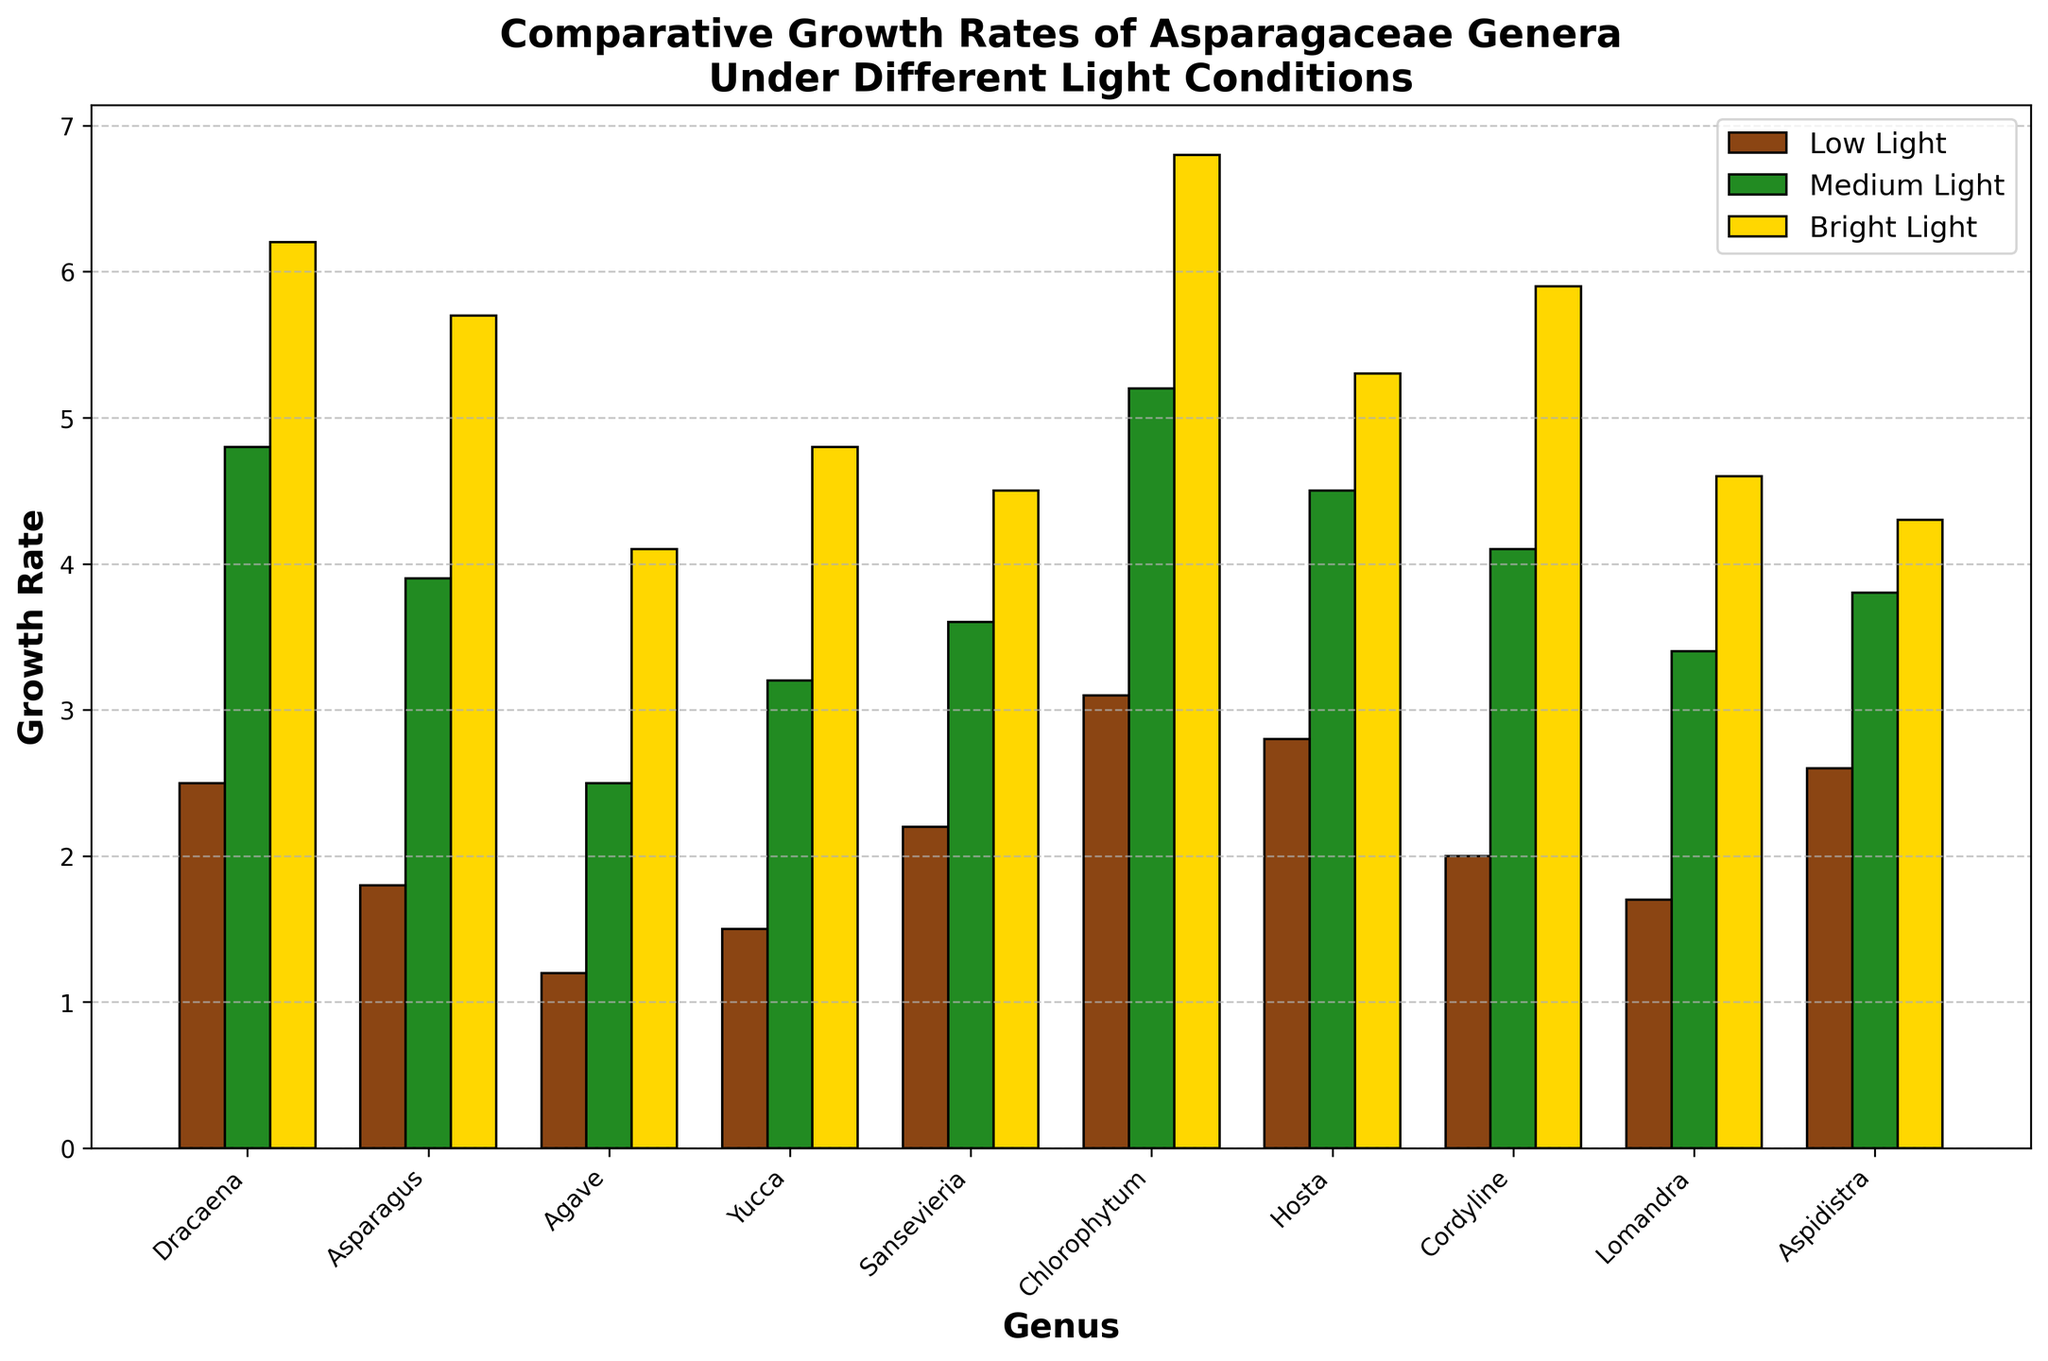Which genus has the highest growth rate under bright light? Look at the “Bright Light” bars and identify the tallest one. Chlorophytum has the highest growth rate of 6.8.
Answer: Chlorophytum Which genus shows the smallest difference in growth rate between low light and bright light conditions? Calculate the differences for each genus: Dracaena (6.2 - 2.5 = 3.7), Asparagus (5.7 - 1.8 = 3.9), Agave (4.1 - 1.2 = 2.9), Yucca (4.8 - 1.5 = 3.3), Sansevieria (4.5 - 2.2 = 2.3), Chlorophytum (6.8 - 3.1 = 3.7), Hosta (5.3 - 2.8 = 2.5), Cordyline (5.9 - 2.0 = 3.9), Lomandra (4.6 - 1.7 = 2.9), Aspidistra (4.3 - 2.6 = 1.7). Aspidistra shows the smallest difference of 1.7.
Answer: Aspidistra Which genera have higher growth rates in medium light compared to bright light? Compare the heights of the “Medium Light” and “Bright Light” bars for each genus. None of the genera have higher growth rates in medium light conditions compared to bright light.
Answer: None What's the average growth rate of Dracaena across all light conditions? Sum the growth rates for Dracaena and divide by 3: (2.5 + 4.8 + 6.2) / 3 = 13.5 / 3. The average is 4.5.
Answer: 4.5 Rank the growth rates under low light conditions from highest to lowest. Compare the heights of the “Low Light” bars for each genus: Chlorophytum (3.1), Hosta (2.8), Aspidistra (2.6), Dracaena (2.5), Sansevieria (2.2), Cordyline (2.0), Asparagus (1.8), Lomandra (1.7), Yucca (1.5), Agave (1.2).
Answer: Chlorophytum, Hosta, Aspidistra, Dracaena, Sansevieria, Cordyline, Asparagus, Lomandra, Yucca, Agave What’s the sum of the growth rates of Agave under all light conditions? Sum the values for Agave: 1.2 (Low Light) + 2.5 (Medium Light) + 4.1 (Bright Light) = 7.8.
Answer: 7.8 Which genus has the closest growth rates under medium light and bright light conditions? Calculate the absolute differences for each genus: Dracaena (1.4), Asparagus (1.8), Agave (1.6), Yucca (1.6), Sansevieria (0.9), Chlorophytum (1.6), Hosta (0.8), Cordyline (1.8), Lomandra (1.2), Aspidistra (0.5). Aspidistra has the closest growth rates with a difference of 0.5.
Answer: Aspidistra 